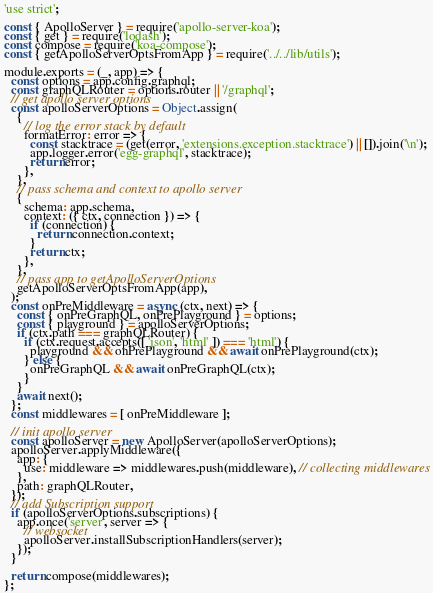<code> <loc_0><loc_0><loc_500><loc_500><_JavaScript_>'use strict';

const { ApolloServer } = require('apollo-server-koa');
const { get } = require('lodash');
const compose = require('koa-compose');
const { getApolloServerOptsFromApp } = require('../../lib/utils');

module.exports = (_, app) => {
  const options = app.config.graphql;
  const graphQLRouter = options.router || '/graphql';
  // get apollo server options
  const apolloServerOptions = Object.assign(
    {
      // log the error stack by default
      formatError: error => {
        const stacktrace = (get(error, 'extensions.exception.stacktrace') || []).join('\n');
        app.logger.error('egg-graphql', stacktrace);
        return error;
      },
    },
    // pass schema and context to apollo server
    {
      schema: app.schema,
      context: ({ ctx, connection }) => {
        if (connection) {
          return connection.context;
        }
        return ctx;
      },
    },
    // pass app to getApolloServerOptions
    getApolloServerOptsFromApp(app),
  );
  const onPreMiddleware = async (ctx, next) => {
    const { onPreGraphQL, onPrePlayground } = options;
    const { playground } = apolloServerOptions;
    if (ctx.path === graphQLRouter) {
      if (ctx.request.accepts([ 'json', 'html' ]) === 'html') {
        playground && onPrePlayground && await onPrePlayground(ctx);
      } else {
        onPreGraphQL && await onPreGraphQL(ctx);
      }
    }
    await next();
  };
  const middlewares = [ onPreMiddleware ];

  // init apollo server
  const apolloServer = new ApolloServer(apolloServerOptions);
  apolloServer.applyMiddleware({
    app: {
      use: middleware => middlewares.push(middleware), // collecting middlewares
    },
    path: graphQLRouter,
  });
  // add Subscription support
  if (apolloServerOptions.subscriptions) {
    app.once('server', server => {
      // websocket
      apolloServer.installSubscriptionHandlers(server);
    });
  }

  return compose(middlewares);
};
</code> 